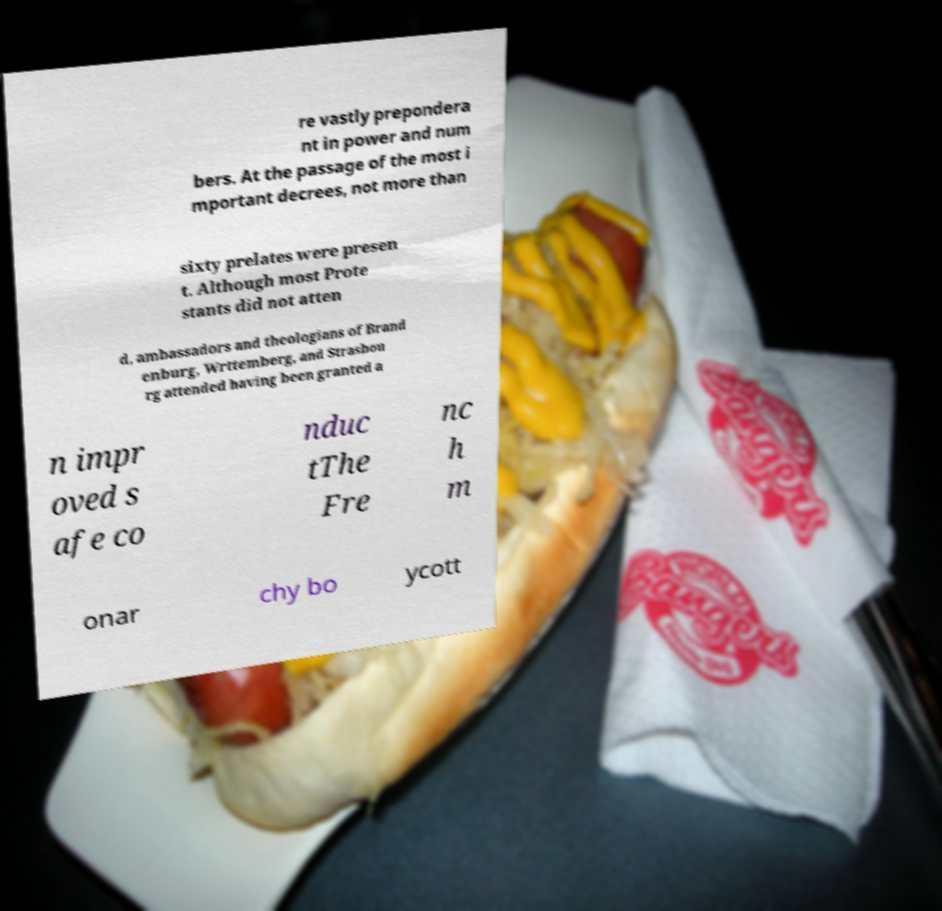Please read and relay the text visible in this image. What does it say? re vastly prepondera nt in power and num bers. At the passage of the most i mportant decrees, not more than sixty prelates were presen t. Although most Prote stants did not atten d, ambassadors and theologians of Brand enburg, Wrttemberg, and Strasbou rg attended having been granted a n impr oved s afe co nduc tThe Fre nc h m onar chy bo ycott 